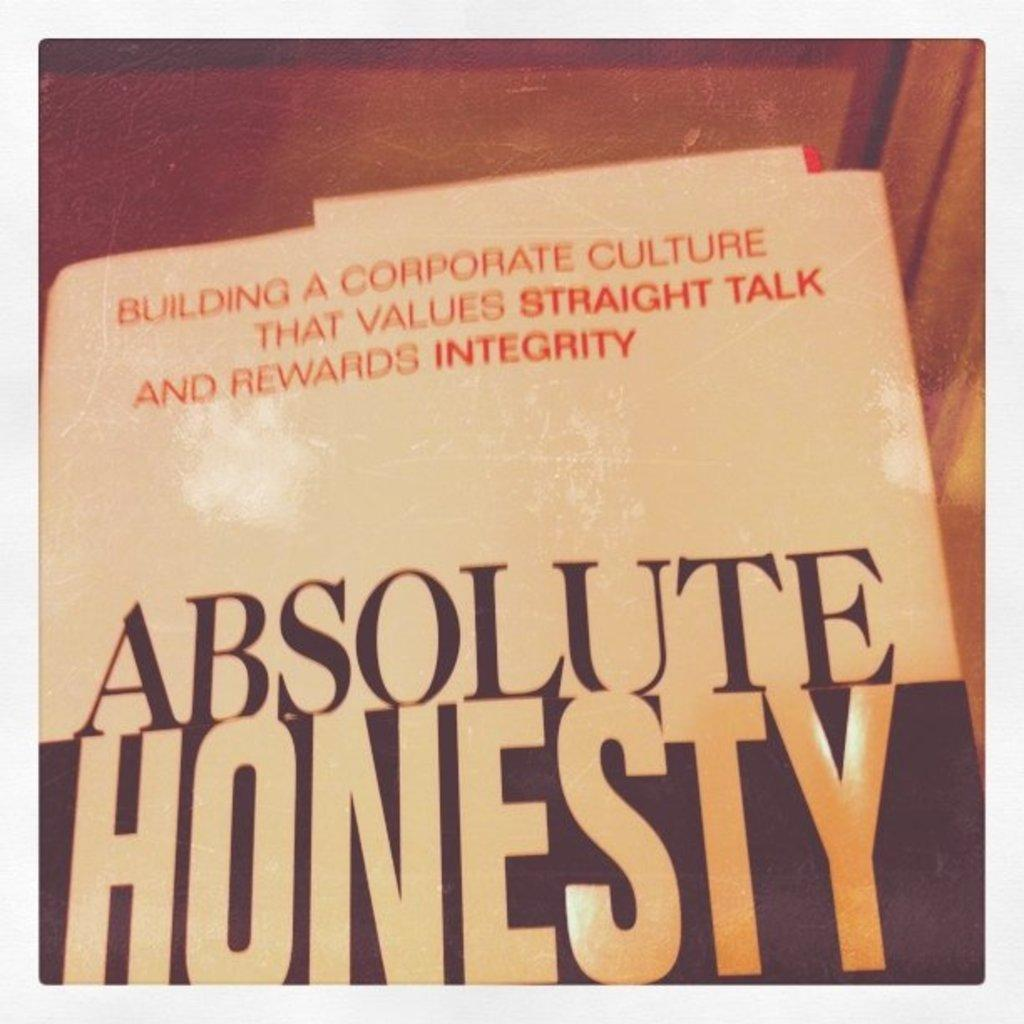Provide a one-sentence caption for the provided image. the word honesty is on a book about integrity. 